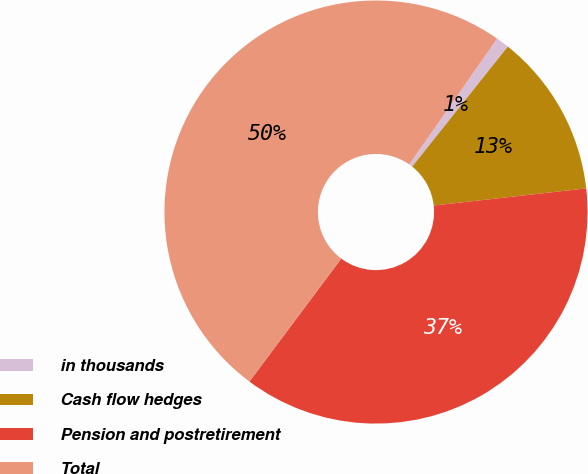Convert chart. <chart><loc_0><loc_0><loc_500><loc_500><pie_chart><fcel>in thousands<fcel>Cash flow hedges<fcel>Pension and postretirement<fcel>Total<nl><fcel>1.0%<fcel>12.51%<fcel>36.99%<fcel>49.5%<nl></chart> 